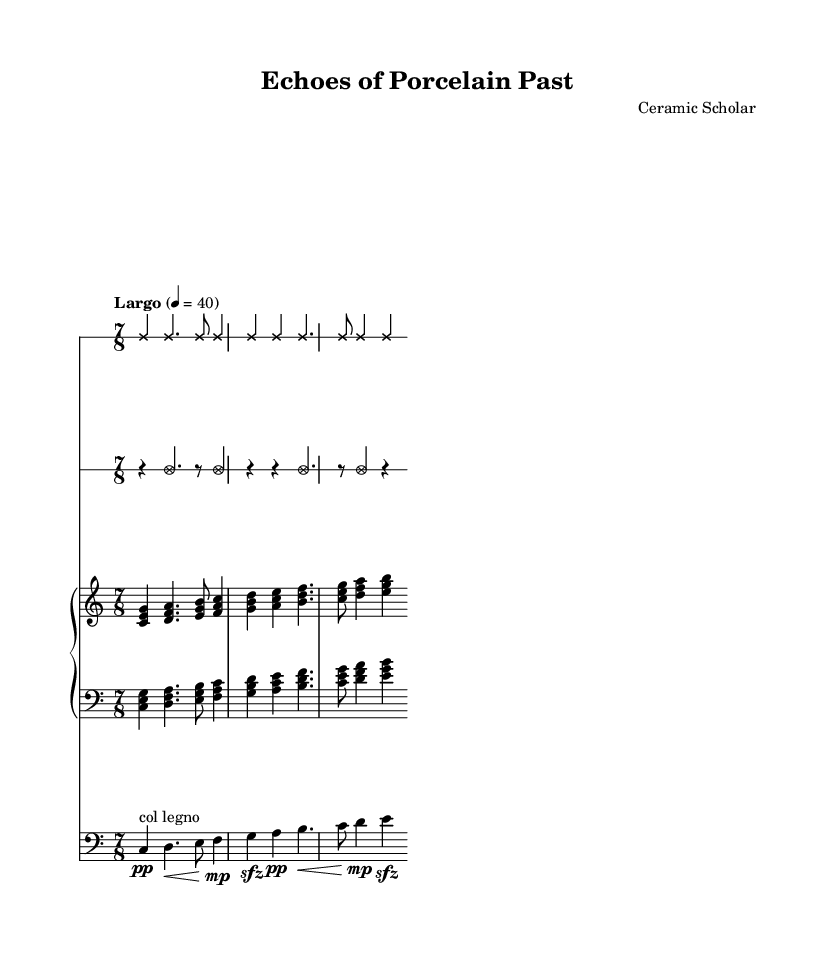What is the time signature of this piece? The time signature is indicated at the beginning of the staff with a "7/8," which shows there are seven beats in each measure and the eighth note gets one beat.
Answer: 7/8 What is the tempo marking for the score? The tempo marking at the start specifies "Largo," which indicates a slow tempo, typically ranging around 40 beats per minute as noted in the accompanying metronome marking.
Answer: Largo How many lines does the staff for porcelain cups have? The staff for porcelain cups is set to have one line, which is indicated by the override setting in the code.
Answer: 1 What is the dynamic marking for the cello in the first measure? In the first measure of the cello part, the dynamic marking is "pp," indicating a very soft volume, as noted next to the note.
Answer: pp Which instruments are involved in this composition? The composition includes porcelain cups, porcelain plates, piano, and cello, as indicated by the staff names and types presented at the beginning of each section.
Answer: Porcelain cups, porcelain plates, piano, cello What type of note head style is used for porcelain plates? The note head style for porcelain plates is indicated as "xcircle," which alters the appearance of these specific notes on the staff to be visually distinct.
Answer: xcircle How does the composer indicate a sudden change in dynamics for the cello? The composer indicates a sudden dynamic change with "sfz," which stands for sforzando, meaning to play the note suddenly with strong emphasis at the marked spots.
Answer: sfz 